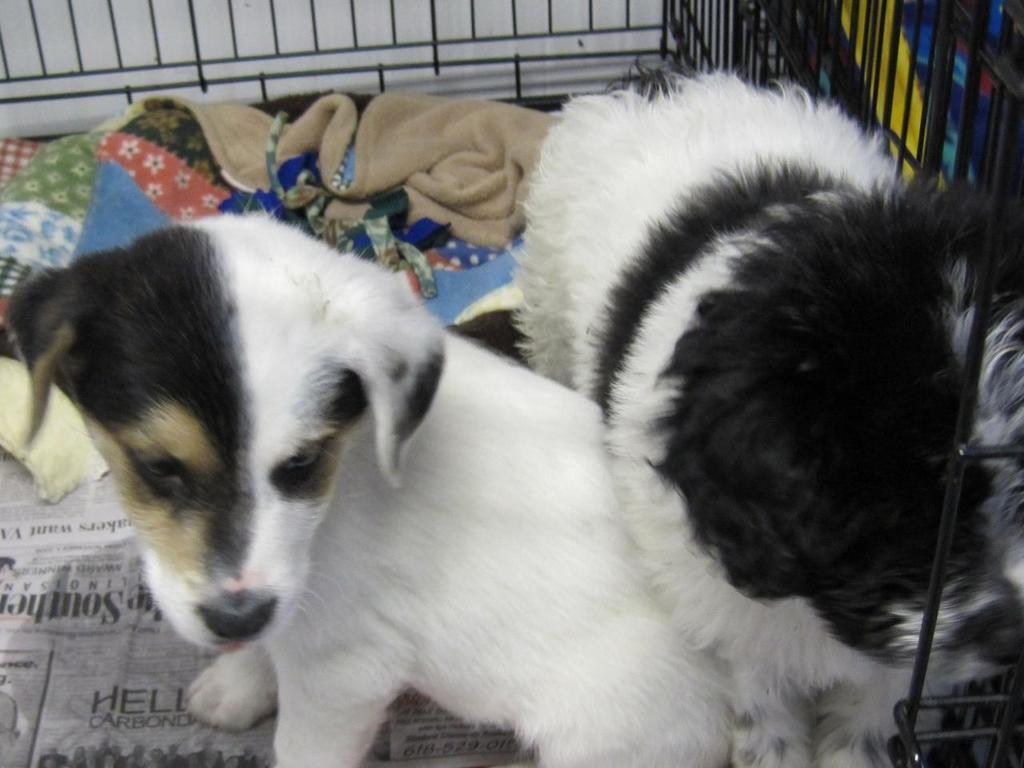Can you describe this image briefly? In this image I can see a dog which is white, black and cream in color is in the black colored metal cage. I can see few clothes and few papers in the cage. 